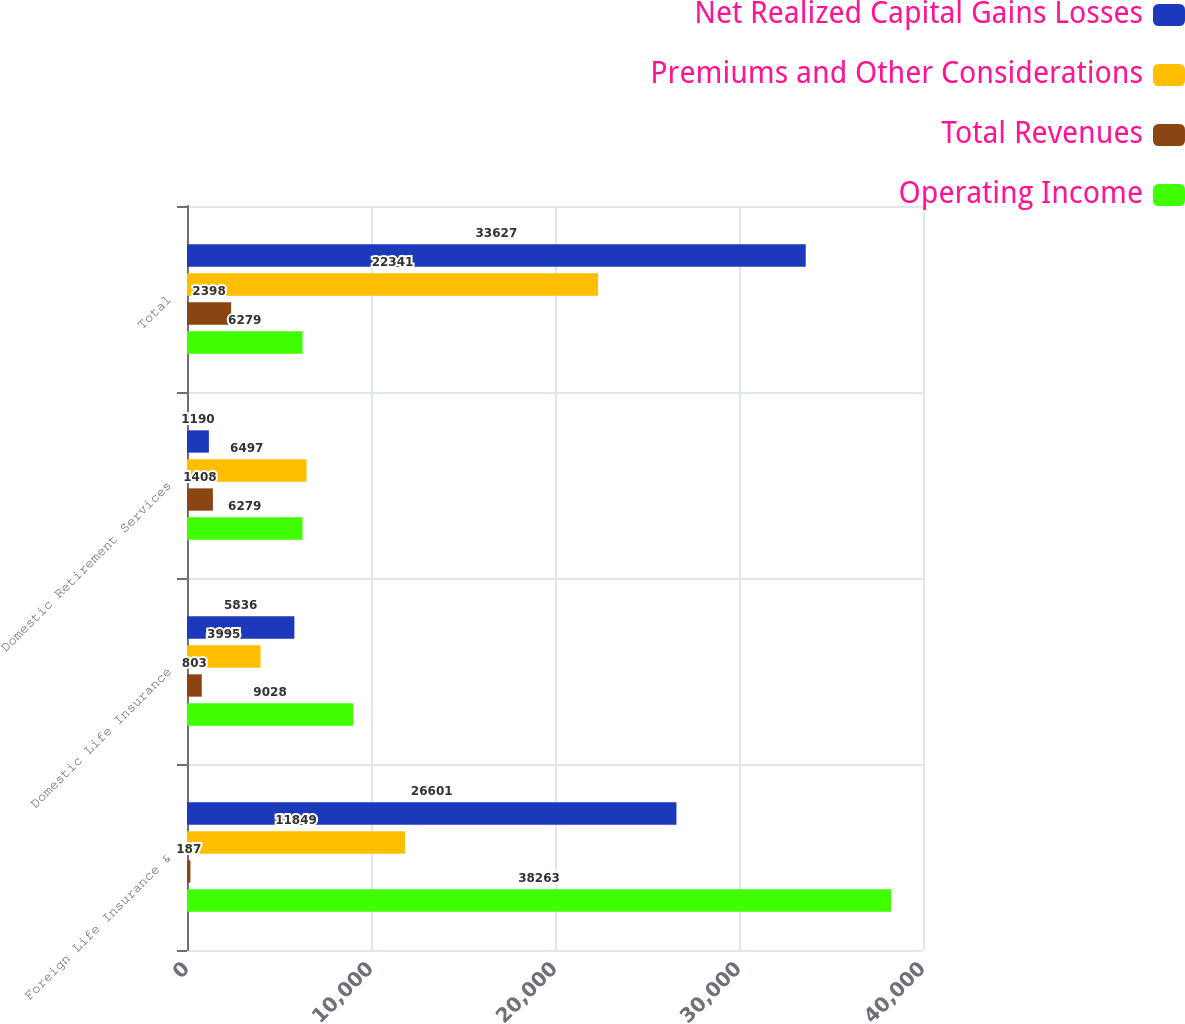Convert chart to OTSL. <chart><loc_0><loc_0><loc_500><loc_500><stacked_bar_chart><ecel><fcel>Foreign Life Insurance &<fcel>Domestic Life Insurance<fcel>Domestic Retirement Services<fcel>Total<nl><fcel>Net Realized Capital Gains Losses<fcel>26601<fcel>5836<fcel>1190<fcel>33627<nl><fcel>Premiums and Other Considerations<fcel>11849<fcel>3995<fcel>6497<fcel>22341<nl><fcel>Total Revenues<fcel>187<fcel>803<fcel>1408<fcel>2398<nl><fcel>Operating Income<fcel>38263<fcel>9028<fcel>6279<fcel>6279<nl></chart> 